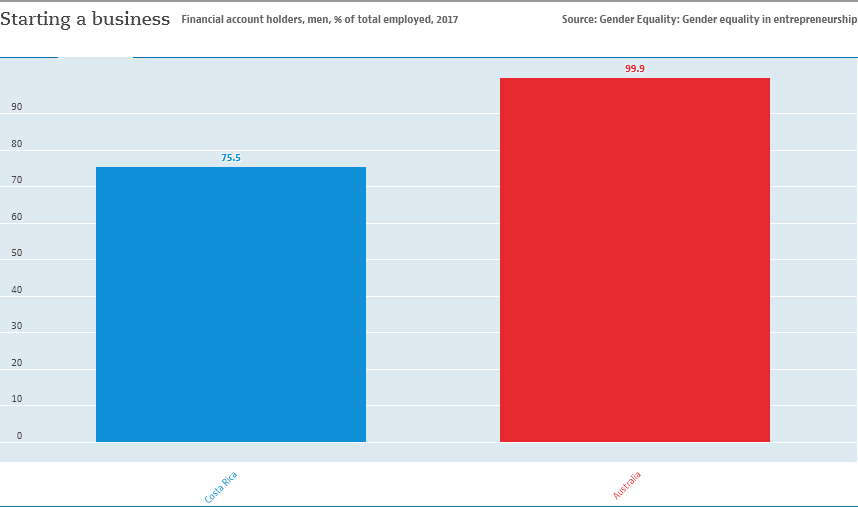Indicate a few pertinent items in this graphic. The two bar distribution has a distinct difference compared to the previous one, with a minimum value of 24.4. The chart contains two categories. 